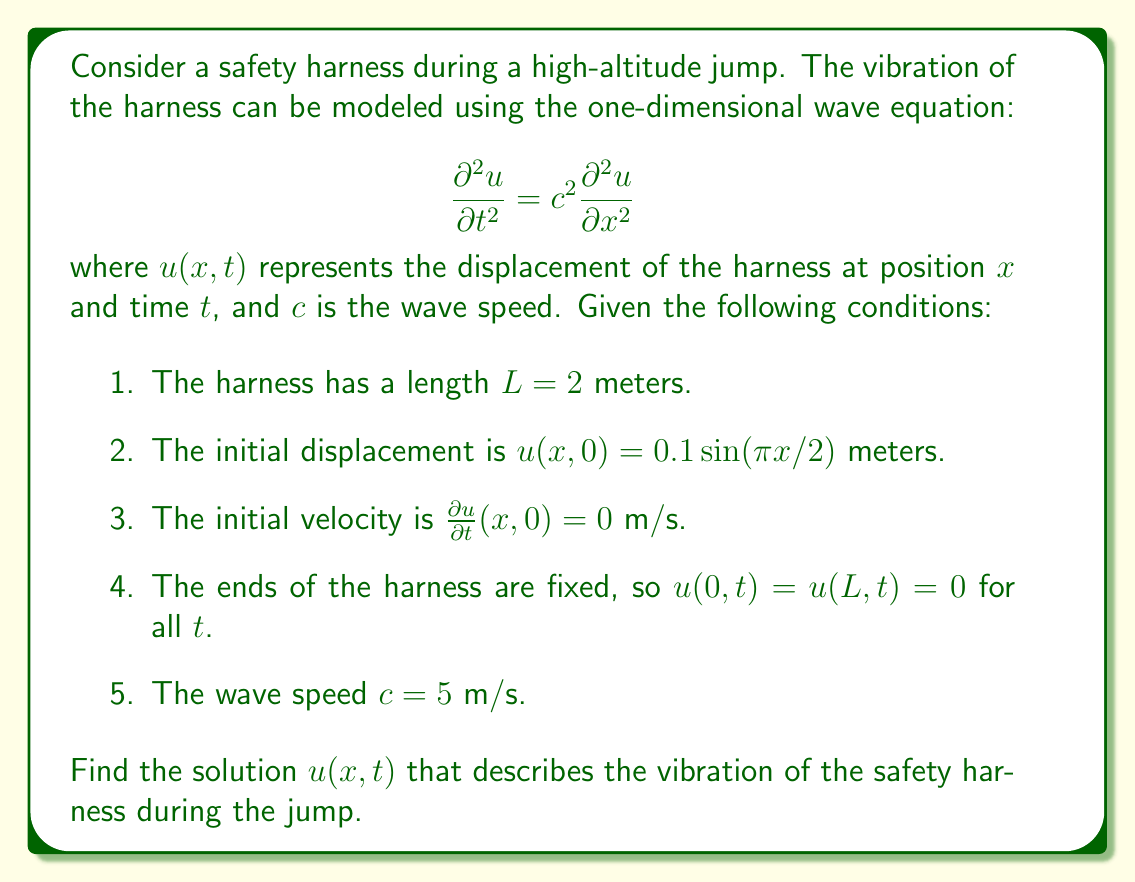Help me with this question. To solve this wave equation problem, we'll use the method of separation of variables and apply the given initial and boundary conditions.

Step 1: Assume a solution of the form $u(x,t) = X(x)T(t)$.

Step 2: Substitute this into the wave equation:
$$X(x)T''(t) = c^2X''(x)T(t)$$
$$\frac{T''(t)}{c^2T(t)} = \frac{X''(x)}{X(x)} = -k^2$$

This gives us two ordinary differential equations:
$$T''(t) + c^2k^2T(t) = 0$$
$$X''(x) + k^2X(x) = 0$$

Step 3: Solve the spatial equation $X''(x) + k^2X(x) = 0$ with boundary conditions $X(0) = X(L) = 0$:
$$X(x) = A \sin(kx)$$
where $k = \frac{n\pi}{L}$ for $n = 1, 2, 3, ...$

Step 4: Solve the temporal equation $T''(t) + c^2k^2T(t) = 0$:
$$T(t) = B \cos(ckt) + C \sin(ckt)$$

Step 5: Combine the solutions:
$$u(x,t) = \sum_{n=1}^{\infty} (B_n \cos(ckt) + C_n \sin(ckt)) \sin(\frac{n\pi x}{L})$$

Step 6: Apply the initial conditions:
$$u(x,0) = 0.1 \sin(\pi x/2) = \sum_{n=1}^{\infty} B_n \sin(\frac{n\pi x}{L})$$
$$\frac{\partial u}{\partial t}(x,0) = 0 = \sum_{n=1}^{\infty} C_n ck \sin(\frac{n\pi x}{L})$$

From these, we can deduce that $C_n = 0$ for all $n$, and $B_n = 0$ for all $n$ except $n = 1$, where $B_1 = 0.1$.

Step 7: Substitute the values:
$$u(x,t) = 0.1 \cos(\frac{c\pi t}{L}) \sin(\frac{\pi x}{L})$$

Step 8: Replace $L$ with 2 and $c$ with 5:
$$u(x,t) = 0.1 \cos(\frac{5\pi t}{2}) \sin(\frac{\pi x}{2})$$

This is the final solution describing the vibration of the safety harness during the high-altitude jump.
Answer: $$u(x,t) = 0.1 \cos(\frac{5\pi t}{2}) \sin(\frac{\pi x}{2})$$ 